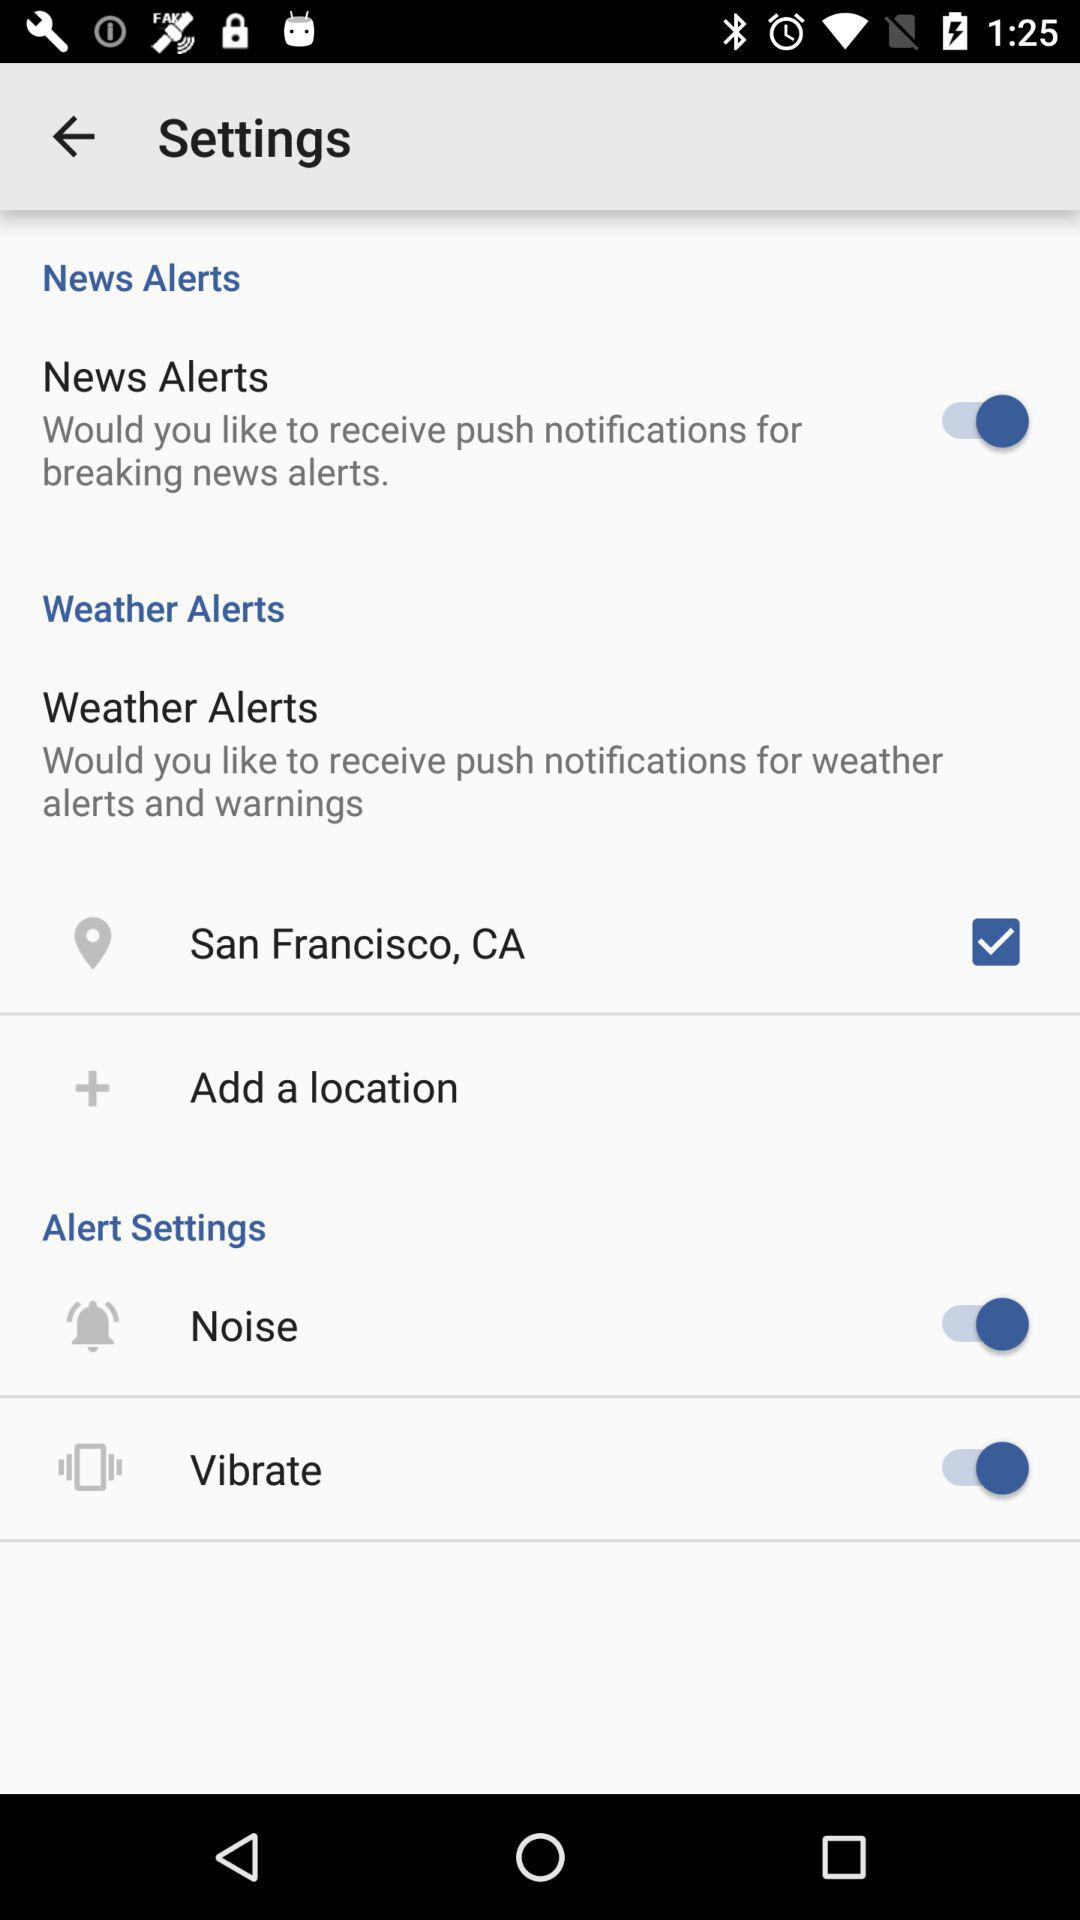What is the status of "News Alerts"? The status is "on". 